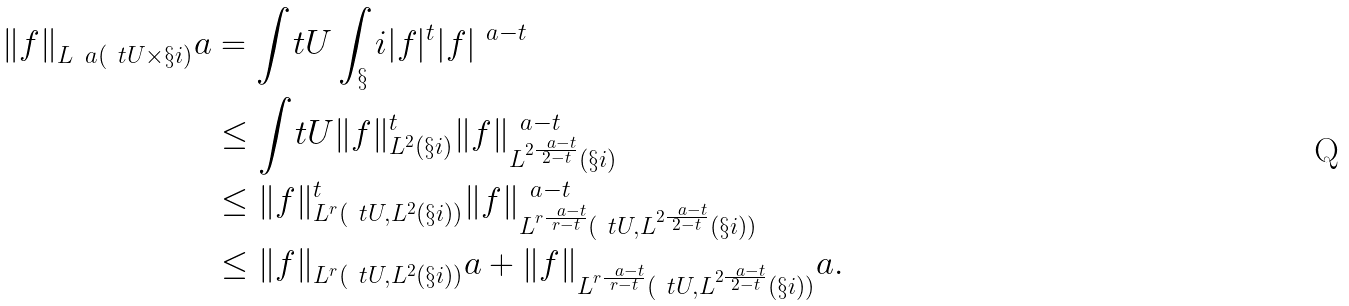<formula> <loc_0><loc_0><loc_500><loc_500>\| f \| _ { L ^ { \ } a ( \ t U \times \S i ) } ^ { \ } a & = \int _ { \ } t U \int _ { \S } i | f | ^ { t } | f | ^ { \ a - t } \\ & \leq \int _ { \ } t U \| f \| _ { L ^ { 2 } ( \S i ) } ^ { t } \| f \| _ { L ^ { 2 \frac { \ a - t } { 2 - t } } ( \S i ) } ^ { \ a - t } \\ & \leq \| f \| _ { L ^ { r } ( \ t U , L ^ { 2 } ( \S i ) ) } ^ { t } \| f \| _ { L ^ { r \frac { \ a - t } { r - t } } ( \ t U , L ^ { 2 \frac { \ a - t } { 2 - t } } ( \S i ) ) } ^ { \ a - t } \\ & \leq \| f \| _ { L ^ { r } ( \ t U , L ^ { 2 } ( \S i ) ) } ^ { \ } a + \| f \| _ { L ^ { r \frac { \ a - t } { r - t } } ( \ t U , L ^ { 2 \frac { \ a - t } { 2 - t } } ( \S i ) ) } ^ { \ } a .</formula> 